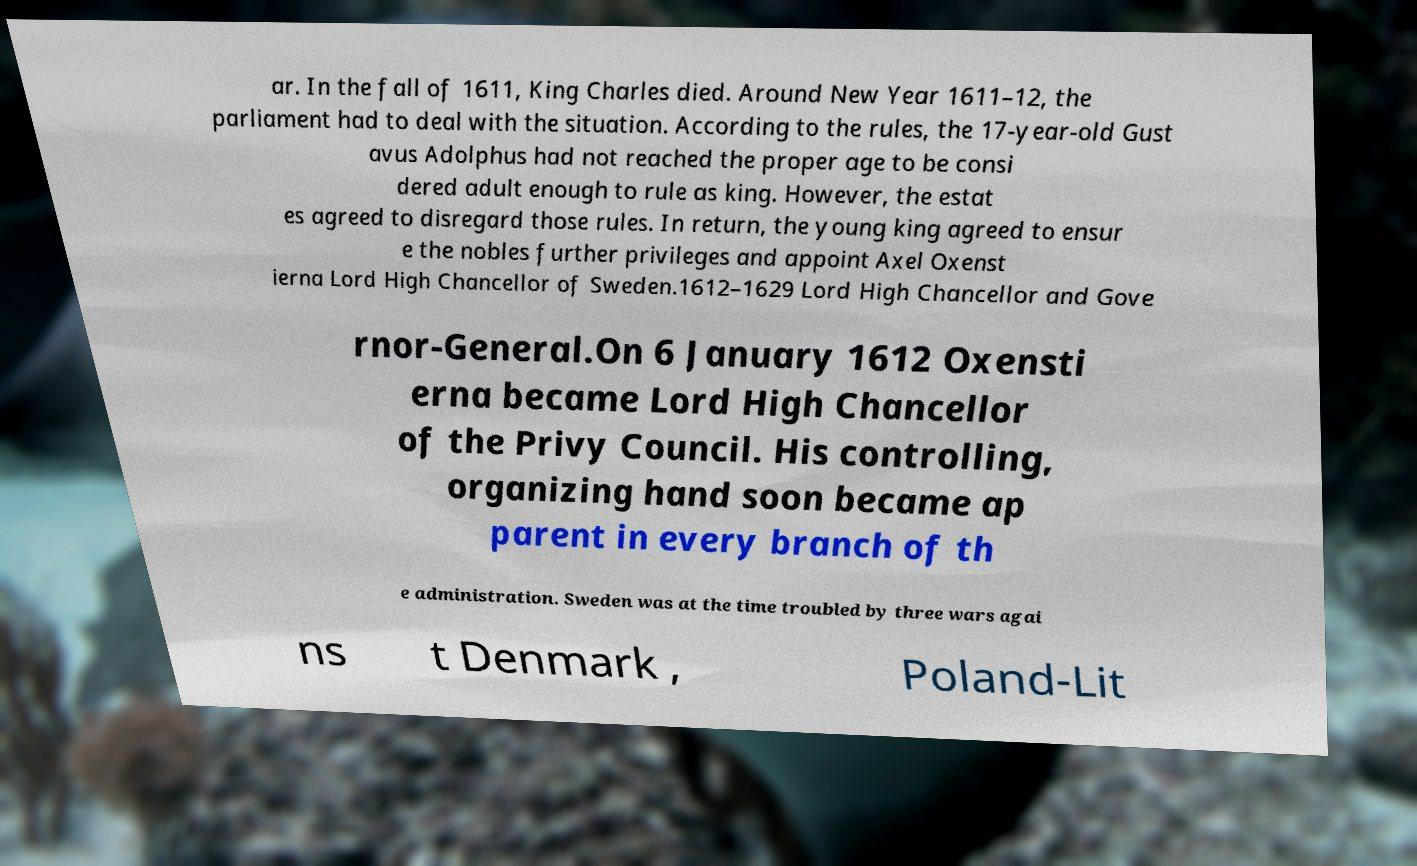What messages or text are displayed in this image? I need them in a readable, typed format. ar. In the fall of 1611, King Charles died. Around New Year 1611–12, the parliament had to deal with the situation. According to the rules, the 17-year-old Gust avus Adolphus had not reached the proper age to be consi dered adult enough to rule as king. However, the estat es agreed to disregard those rules. In return, the young king agreed to ensur e the nobles further privileges and appoint Axel Oxenst ierna Lord High Chancellor of Sweden.1612–1629 Lord High Chancellor and Gove rnor-General.On 6 January 1612 Oxensti erna became Lord High Chancellor of the Privy Council. His controlling, organizing hand soon became ap parent in every branch of th e administration. Sweden was at the time troubled by three wars agai ns t Denmark , Poland-Lit 